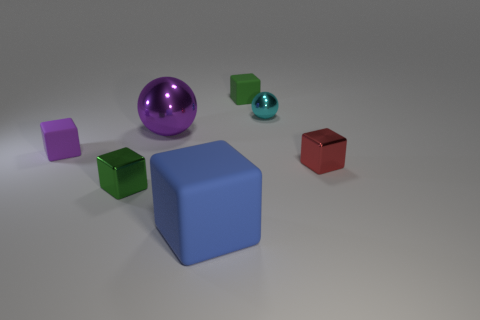How many rubber things have the same color as the small ball?
Ensure brevity in your answer.  0. What material is the tiny green block that is behind the red cube?
Ensure brevity in your answer.  Rubber. What number of large things are either purple objects or green shiny cubes?
Your response must be concise. 1. Are there any purple blocks made of the same material as the red cube?
Offer a very short reply. No. There is a matte thing that is in front of the purple rubber cube; is its size the same as the purple rubber cube?
Provide a succinct answer. No. Is there a cyan sphere in front of the cube that is left of the tiny metallic cube that is on the left side of the large block?
Provide a succinct answer. No. What number of metallic objects are large purple spheres or big blue things?
Ensure brevity in your answer.  1. What number of other things are there of the same shape as the small purple matte thing?
Offer a terse response. 4. Is the number of blue blocks greater than the number of red matte balls?
Keep it short and to the point. Yes. What size is the purple thing behind the tiny block left of the small green thing that is left of the tiny green rubber cube?
Provide a short and direct response. Large. 